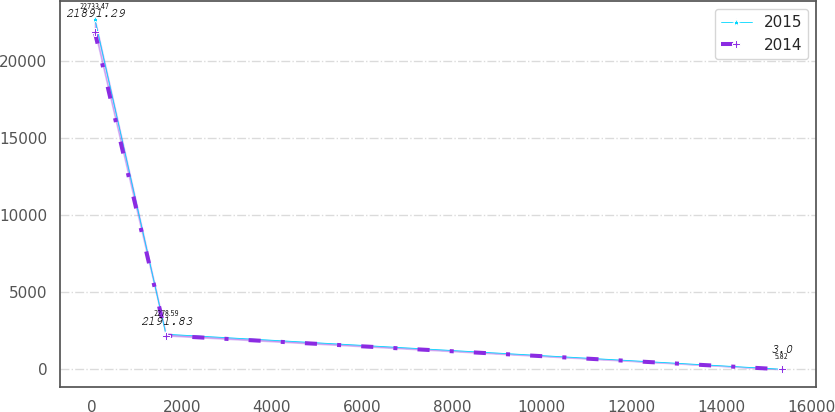Convert chart to OTSL. <chart><loc_0><loc_0><loc_500><loc_500><line_chart><ecel><fcel>2015<fcel>2014<nl><fcel>64.41<fcel>22733.5<fcel>21891.3<nl><fcel>1645.23<fcel>2278.59<fcel>2191.83<nl><fcel>15330.4<fcel>5.82<fcel>3<nl></chart> 